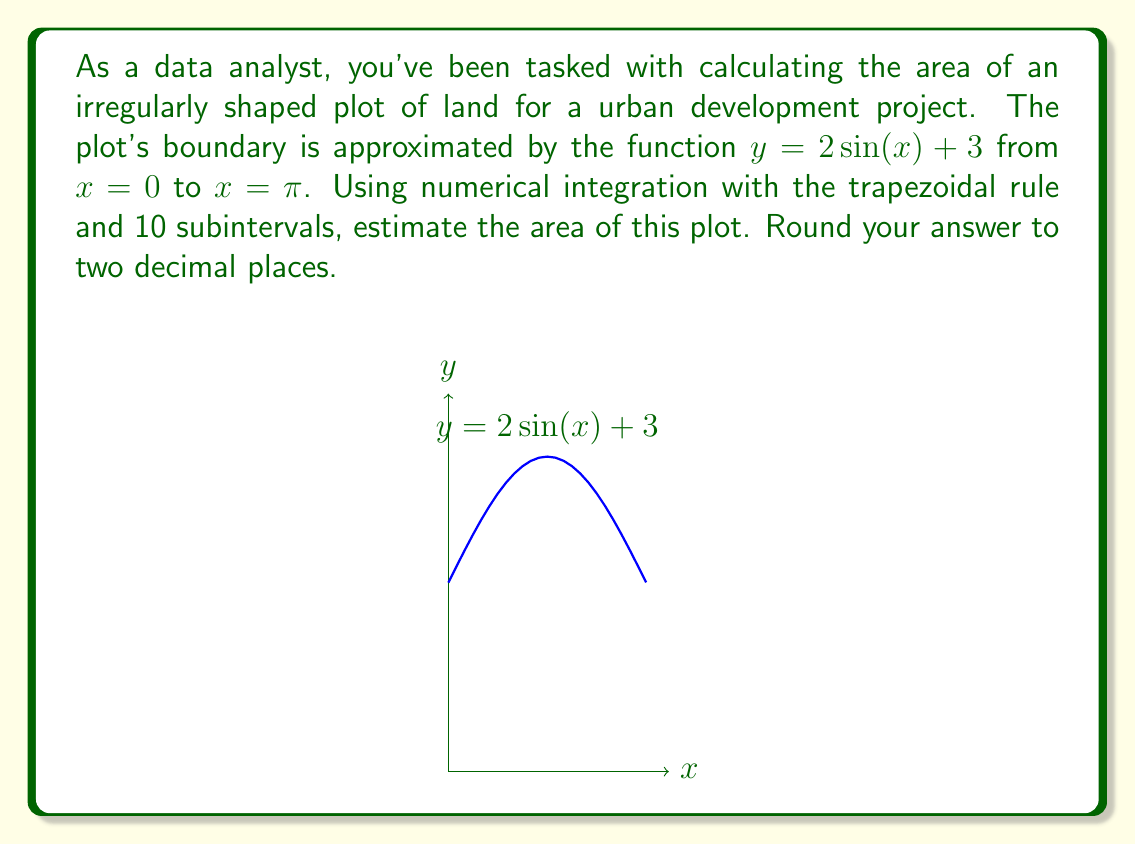Can you solve this math problem? To solve this problem, we'll use the trapezoidal rule for numerical integration. The steps are as follows:

1) The trapezoidal rule formula for n subintervals is:

   $$\int_{a}^{b} f(x)dx \approx \frac{b-a}{2n}[f(a) + 2f(x_1) + 2f(x_2) + ... + 2f(x_{n-1}) + f(b)]$$

2) Here, $a=0$, $b=\pi$, $n=10$, and $f(x) = 2\sin(x) + 3$

3) We need to calculate $f(x)$ at 11 points (0 to 10 inclusive), where $x_i = a + i\frac{b-a}{n}$:

   $x_0 = 0$
   $x_1 = \frac{\pi}{10}$
   $x_2 = \frac{2\pi}{10}$
   ...
   $x_9 = \frac{9\pi}{10}$
   $x_{10} = \pi$

4) Calculate $f(x)$ for each point:

   $f(x_0) = 2\sin(0) + 3 = 3$
   $f(x_1) = 2\sin(\frac{\pi}{10}) + 3 \approx 3.618$
   $f(x_2) = 2\sin(\frac{2\pi}{10}) + 3 \approx 4.191$
   ...
   $f(x_9) = 2\sin(\frac{9\pi}{10}) + 3 \approx 4.191$
   $f(x_{10}) = 2\sin(\pi) + 3 = 3$

5) Apply the trapezoidal rule:

   $$Area \approx \frac{\pi-0}{2(10)}[3 + 2(3.618 + 4.191 + ... + 4.191) + 3]$$

6) Simplifying and calculating:

   $$Area \approx 0.157 * [3 + 2(34.764) + 3] \approx 11.33$$

Therefore, the estimated area of the plot is approximately 11.33 square units.
Answer: 11.33 square units 